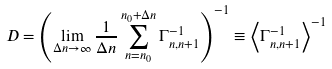<formula> <loc_0><loc_0><loc_500><loc_500>D = \left ( \lim _ { \Delta n \to \infty } \frac { 1 } { \Delta n } \sum _ { n = n _ { 0 } } ^ { n _ { 0 } { + } \Delta n } \Gamma _ { n , n + 1 } ^ { - 1 } \right ) ^ { - 1 } \equiv \left \langle \Gamma _ { n , n + 1 } ^ { - 1 } \right \rangle ^ { - 1 }</formula> 